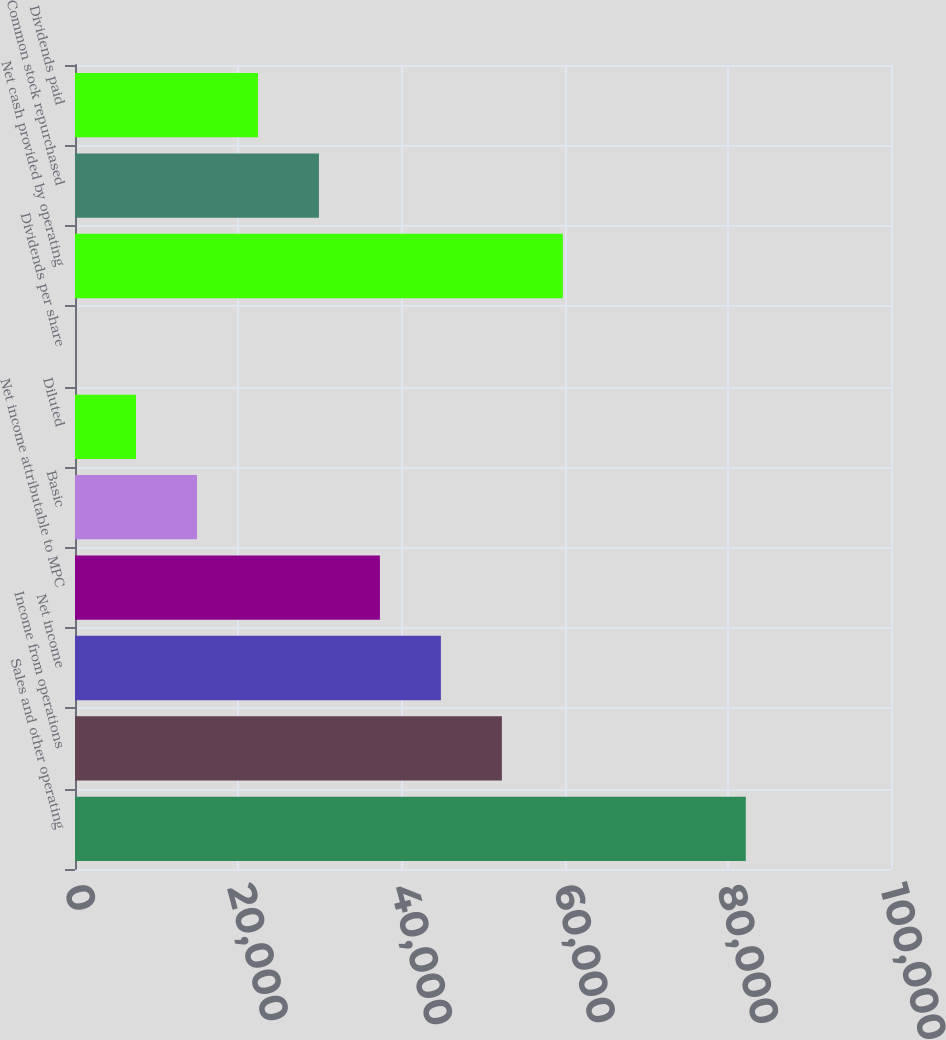Convert chart. <chart><loc_0><loc_0><loc_500><loc_500><bar_chart><fcel>Sales and other operating<fcel>Income from operations<fcel>Net income<fcel>Net income attributable to MPC<fcel>Basic<fcel>Diluted<fcel>Dividends per share<fcel>Net cash provided by operating<fcel>Common stock repurchased<fcel>Dividends paid<nl><fcel>82206.2<fcel>52313.6<fcel>44840.4<fcel>37367.3<fcel>14947.8<fcel>7474.67<fcel>1.52<fcel>59786.7<fcel>29894.1<fcel>22421<nl></chart> 